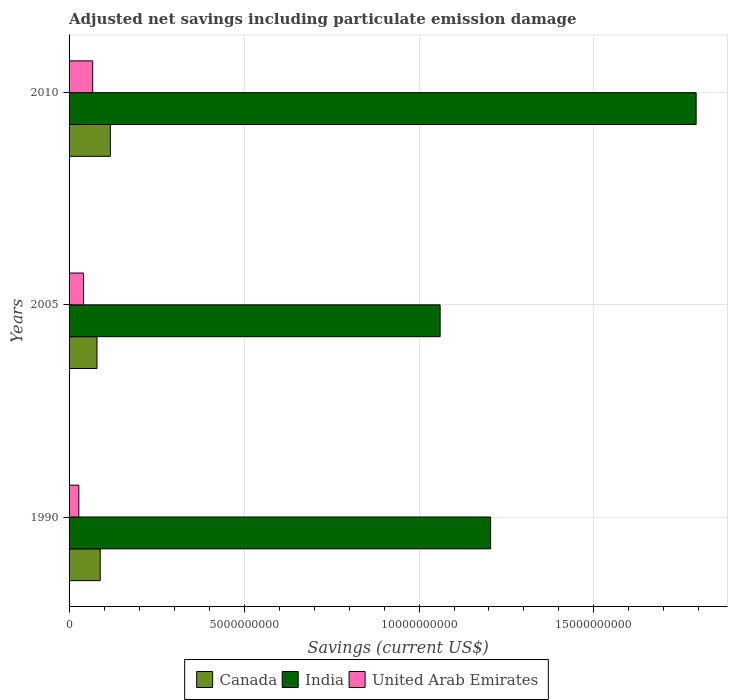Are the number of bars on each tick of the Y-axis equal?
Your answer should be compact. Yes. What is the net savings in India in 2010?
Make the answer very short. 1.79e+1. Across all years, what is the maximum net savings in Canada?
Ensure brevity in your answer.  1.18e+09. Across all years, what is the minimum net savings in United Arab Emirates?
Make the answer very short. 2.79e+08. In which year was the net savings in United Arab Emirates maximum?
Make the answer very short. 2010. In which year was the net savings in United Arab Emirates minimum?
Keep it short and to the point. 1990. What is the total net savings in Canada in the graph?
Offer a terse response. 2.87e+09. What is the difference between the net savings in India in 2005 and that in 2010?
Keep it short and to the point. -7.32e+09. What is the difference between the net savings in Canada in 1990 and the net savings in India in 2010?
Your answer should be compact. -1.70e+1. What is the average net savings in United Arab Emirates per year?
Provide a short and direct response. 4.55e+08. In the year 2005, what is the difference between the net savings in Canada and net savings in India?
Give a very brief answer. -9.81e+09. In how many years, is the net savings in Canada greater than 6000000000 US$?
Give a very brief answer. 0. What is the ratio of the net savings in India in 2005 to that in 2010?
Your response must be concise. 0.59. Is the net savings in United Arab Emirates in 1990 less than that in 2005?
Provide a short and direct response. Yes. What is the difference between the highest and the second highest net savings in Canada?
Keep it short and to the point. 2.90e+08. What is the difference between the highest and the lowest net savings in Canada?
Provide a short and direct response. 3.82e+08. In how many years, is the net savings in Canada greater than the average net savings in Canada taken over all years?
Your answer should be compact. 1. Is the sum of the net savings in India in 1990 and 2005 greater than the maximum net savings in Canada across all years?
Give a very brief answer. Yes. What does the 3rd bar from the top in 2010 represents?
Ensure brevity in your answer.  Canada. What does the 3rd bar from the bottom in 2010 represents?
Make the answer very short. United Arab Emirates. Are all the bars in the graph horizontal?
Provide a short and direct response. Yes. How many years are there in the graph?
Make the answer very short. 3. What is the difference between two consecutive major ticks on the X-axis?
Your answer should be very brief. 5.00e+09. Does the graph contain any zero values?
Provide a short and direct response. No. Where does the legend appear in the graph?
Your response must be concise. Bottom center. What is the title of the graph?
Provide a succinct answer. Adjusted net savings including particulate emission damage. Does "Burkina Faso" appear as one of the legend labels in the graph?
Ensure brevity in your answer.  No. What is the label or title of the X-axis?
Your response must be concise. Savings (current US$). What is the label or title of the Y-axis?
Keep it short and to the point. Years. What is the Savings (current US$) of Canada in 1990?
Your answer should be compact. 8.90e+08. What is the Savings (current US$) in India in 1990?
Offer a very short reply. 1.20e+1. What is the Savings (current US$) of United Arab Emirates in 1990?
Ensure brevity in your answer.  2.79e+08. What is the Savings (current US$) in Canada in 2005?
Offer a very short reply. 7.98e+08. What is the Savings (current US$) in India in 2005?
Your answer should be very brief. 1.06e+1. What is the Savings (current US$) of United Arab Emirates in 2005?
Provide a short and direct response. 4.12e+08. What is the Savings (current US$) of Canada in 2010?
Offer a very short reply. 1.18e+09. What is the Savings (current US$) in India in 2010?
Provide a succinct answer. 1.79e+1. What is the Savings (current US$) of United Arab Emirates in 2010?
Provide a succinct answer. 6.75e+08. Across all years, what is the maximum Savings (current US$) of Canada?
Keep it short and to the point. 1.18e+09. Across all years, what is the maximum Savings (current US$) of India?
Give a very brief answer. 1.79e+1. Across all years, what is the maximum Savings (current US$) in United Arab Emirates?
Your answer should be compact. 6.75e+08. Across all years, what is the minimum Savings (current US$) of Canada?
Your response must be concise. 7.98e+08. Across all years, what is the minimum Savings (current US$) in India?
Offer a terse response. 1.06e+1. Across all years, what is the minimum Savings (current US$) of United Arab Emirates?
Your response must be concise. 2.79e+08. What is the total Savings (current US$) of Canada in the graph?
Give a very brief answer. 2.87e+09. What is the total Savings (current US$) in India in the graph?
Provide a succinct answer. 4.06e+1. What is the total Savings (current US$) in United Arab Emirates in the graph?
Provide a short and direct response. 1.37e+09. What is the difference between the Savings (current US$) in Canada in 1990 and that in 2005?
Provide a succinct answer. 9.21e+07. What is the difference between the Savings (current US$) of India in 1990 and that in 2005?
Make the answer very short. 1.44e+09. What is the difference between the Savings (current US$) of United Arab Emirates in 1990 and that in 2005?
Your answer should be very brief. -1.34e+08. What is the difference between the Savings (current US$) in Canada in 1990 and that in 2010?
Provide a short and direct response. -2.90e+08. What is the difference between the Savings (current US$) in India in 1990 and that in 2010?
Provide a short and direct response. -5.87e+09. What is the difference between the Savings (current US$) in United Arab Emirates in 1990 and that in 2010?
Offer a very short reply. -3.96e+08. What is the difference between the Savings (current US$) of Canada in 2005 and that in 2010?
Offer a terse response. -3.82e+08. What is the difference between the Savings (current US$) of India in 2005 and that in 2010?
Your answer should be compact. -7.32e+09. What is the difference between the Savings (current US$) of United Arab Emirates in 2005 and that in 2010?
Offer a terse response. -2.62e+08. What is the difference between the Savings (current US$) in Canada in 1990 and the Savings (current US$) in India in 2005?
Ensure brevity in your answer.  -9.71e+09. What is the difference between the Savings (current US$) of Canada in 1990 and the Savings (current US$) of United Arab Emirates in 2005?
Your answer should be very brief. 4.78e+08. What is the difference between the Savings (current US$) of India in 1990 and the Savings (current US$) of United Arab Emirates in 2005?
Keep it short and to the point. 1.16e+1. What is the difference between the Savings (current US$) in Canada in 1990 and the Savings (current US$) in India in 2010?
Your answer should be very brief. -1.70e+1. What is the difference between the Savings (current US$) in Canada in 1990 and the Savings (current US$) in United Arab Emirates in 2010?
Provide a short and direct response. 2.16e+08. What is the difference between the Savings (current US$) of India in 1990 and the Savings (current US$) of United Arab Emirates in 2010?
Keep it short and to the point. 1.14e+1. What is the difference between the Savings (current US$) in Canada in 2005 and the Savings (current US$) in India in 2010?
Your answer should be compact. -1.71e+1. What is the difference between the Savings (current US$) of Canada in 2005 and the Savings (current US$) of United Arab Emirates in 2010?
Ensure brevity in your answer.  1.24e+08. What is the difference between the Savings (current US$) of India in 2005 and the Savings (current US$) of United Arab Emirates in 2010?
Your response must be concise. 9.93e+09. What is the average Savings (current US$) in Canada per year?
Your answer should be compact. 9.56e+08. What is the average Savings (current US$) in India per year?
Your response must be concise. 1.35e+1. What is the average Savings (current US$) of United Arab Emirates per year?
Make the answer very short. 4.55e+08. In the year 1990, what is the difference between the Savings (current US$) in Canada and Savings (current US$) in India?
Offer a terse response. -1.12e+1. In the year 1990, what is the difference between the Savings (current US$) in Canada and Savings (current US$) in United Arab Emirates?
Your answer should be compact. 6.12e+08. In the year 1990, what is the difference between the Savings (current US$) in India and Savings (current US$) in United Arab Emirates?
Give a very brief answer. 1.18e+1. In the year 2005, what is the difference between the Savings (current US$) in Canada and Savings (current US$) in India?
Make the answer very short. -9.81e+09. In the year 2005, what is the difference between the Savings (current US$) of Canada and Savings (current US$) of United Arab Emirates?
Your answer should be very brief. 3.86e+08. In the year 2005, what is the difference between the Savings (current US$) in India and Savings (current US$) in United Arab Emirates?
Keep it short and to the point. 1.02e+1. In the year 2010, what is the difference between the Savings (current US$) in Canada and Savings (current US$) in India?
Keep it short and to the point. -1.67e+1. In the year 2010, what is the difference between the Savings (current US$) in Canada and Savings (current US$) in United Arab Emirates?
Make the answer very short. 5.06e+08. In the year 2010, what is the difference between the Savings (current US$) of India and Savings (current US$) of United Arab Emirates?
Give a very brief answer. 1.72e+1. What is the ratio of the Savings (current US$) of Canada in 1990 to that in 2005?
Provide a short and direct response. 1.12. What is the ratio of the Savings (current US$) in India in 1990 to that in 2005?
Your answer should be very brief. 1.14. What is the ratio of the Savings (current US$) in United Arab Emirates in 1990 to that in 2005?
Provide a short and direct response. 0.68. What is the ratio of the Savings (current US$) in Canada in 1990 to that in 2010?
Make the answer very short. 0.75. What is the ratio of the Savings (current US$) in India in 1990 to that in 2010?
Offer a terse response. 0.67. What is the ratio of the Savings (current US$) in United Arab Emirates in 1990 to that in 2010?
Make the answer very short. 0.41. What is the ratio of the Savings (current US$) of Canada in 2005 to that in 2010?
Ensure brevity in your answer.  0.68. What is the ratio of the Savings (current US$) of India in 2005 to that in 2010?
Your response must be concise. 0.59. What is the ratio of the Savings (current US$) in United Arab Emirates in 2005 to that in 2010?
Offer a very short reply. 0.61. What is the difference between the highest and the second highest Savings (current US$) in Canada?
Keep it short and to the point. 2.90e+08. What is the difference between the highest and the second highest Savings (current US$) of India?
Ensure brevity in your answer.  5.87e+09. What is the difference between the highest and the second highest Savings (current US$) of United Arab Emirates?
Give a very brief answer. 2.62e+08. What is the difference between the highest and the lowest Savings (current US$) in Canada?
Give a very brief answer. 3.82e+08. What is the difference between the highest and the lowest Savings (current US$) in India?
Make the answer very short. 7.32e+09. What is the difference between the highest and the lowest Savings (current US$) of United Arab Emirates?
Your answer should be compact. 3.96e+08. 